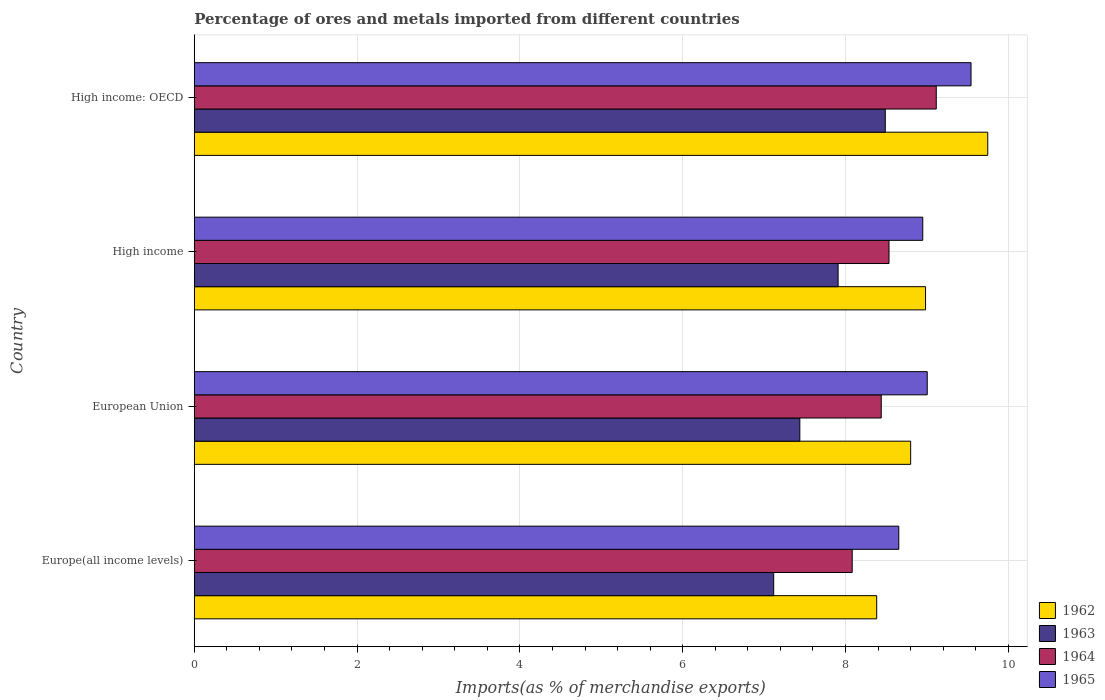How many different coloured bars are there?
Make the answer very short. 4. How many groups of bars are there?
Offer a very short reply. 4. Are the number of bars on each tick of the Y-axis equal?
Your answer should be very brief. Yes. How many bars are there on the 2nd tick from the bottom?
Ensure brevity in your answer.  4. What is the label of the 4th group of bars from the top?
Give a very brief answer. Europe(all income levels). What is the percentage of imports to different countries in 1962 in High income?
Keep it short and to the point. 8.98. Across all countries, what is the maximum percentage of imports to different countries in 1963?
Provide a short and direct response. 8.49. Across all countries, what is the minimum percentage of imports to different countries in 1962?
Provide a short and direct response. 8.38. In which country was the percentage of imports to different countries in 1964 maximum?
Your response must be concise. High income: OECD. In which country was the percentage of imports to different countries in 1962 minimum?
Your answer should be compact. Europe(all income levels). What is the total percentage of imports to different countries in 1965 in the graph?
Your answer should be compact. 36.15. What is the difference between the percentage of imports to different countries in 1962 in European Union and that in High income: OECD?
Make the answer very short. -0.95. What is the difference between the percentage of imports to different countries in 1964 in High income and the percentage of imports to different countries in 1965 in European Union?
Your answer should be compact. -0.47. What is the average percentage of imports to different countries in 1965 per country?
Your answer should be very brief. 9.04. What is the difference between the percentage of imports to different countries in 1962 and percentage of imports to different countries in 1965 in European Union?
Offer a very short reply. -0.2. In how many countries, is the percentage of imports to different countries in 1962 greater than 8.4 %?
Ensure brevity in your answer.  3. What is the ratio of the percentage of imports to different countries in 1962 in European Union to that in High income?
Your response must be concise. 0.98. What is the difference between the highest and the second highest percentage of imports to different countries in 1962?
Offer a very short reply. 0.76. What is the difference between the highest and the lowest percentage of imports to different countries in 1963?
Provide a short and direct response. 1.37. In how many countries, is the percentage of imports to different countries in 1963 greater than the average percentage of imports to different countries in 1963 taken over all countries?
Provide a short and direct response. 2. What does the 1st bar from the top in Europe(all income levels) represents?
Offer a very short reply. 1965. What does the 1st bar from the bottom in High income represents?
Provide a short and direct response. 1962. How many bars are there?
Your response must be concise. 16. What is the difference between two consecutive major ticks on the X-axis?
Keep it short and to the point. 2. Are the values on the major ticks of X-axis written in scientific E-notation?
Give a very brief answer. No. Where does the legend appear in the graph?
Provide a succinct answer. Bottom right. How many legend labels are there?
Ensure brevity in your answer.  4. How are the legend labels stacked?
Your answer should be very brief. Vertical. What is the title of the graph?
Offer a very short reply. Percentage of ores and metals imported from different countries. What is the label or title of the X-axis?
Give a very brief answer. Imports(as % of merchandise exports). What is the label or title of the Y-axis?
Offer a very short reply. Country. What is the Imports(as % of merchandise exports) of 1962 in Europe(all income levels)?
Give a very brief answer. 8.38. What is the Imports(as % of merchandise exports) in 1963 in Europe(all income levels)?
Ensure brevity in your answer.  7.12. What is the Imports(as % of merchandise exports) in 1964 in Europe(all income levels)?
Offer a terse response. 8.08. What is the Imports(as % of merchandise exports) of 1965 in Europe(all income levels)?
Your answer should be compact. 8.65. What is the Imports(as % of merchandise exports) of 1962 in European Union?
Offer a very short reply. 8.8. What is the Imports(as % of merchandise exports) of 1963 in European Union?
Give a very brief answer. 7.44. What is the Imports(as % of merchandise exports) in 1964 in European Union?
Your answer should be compact. 8.44. What is the Imports(as % of merchandise exports) of 1965 in European Union?
Ensure brevity in your answer.  9. What is the Imports(as % of merchandise exports) of 1962 in High income?
Keep it short and to the point. 8.98. What is the Imports(as % of merchandise exports) in 1963 in High income?
Give a very brief answer. 7.91. What is the Imports(as % of merchandise exports) in 1964 in High income?
Ensure brevity in your answer.  8.53. What is the Imports(as % of merchandise exports) of 1965 in High income?
Keep it short and to the point. 8.95. What is the Imports(as % of merchandise exports) in 1962 in High income: OECD?
Make the answer very short. 9.75. What is the Imports(as % of merchandise exports) of 1963 in High income: OECD?
Ensure brevity in your answer.  8.49. What is the Imports(as % of merchandise exports) of 1964 in High income: OECD?
Give a very brief answer. 9.11. What is the Imports(as % of merchandise exports) in 1965 in High income: OECD?
Provide a succinct answer. 9.54. Across all countries, what is the maximum Imports(as % of merchandise exports) in 1962?
Your answer should be compact. 9.75. Across all countries, what is the maximum Imports(as % of merchandise exports) in 1963?
Your answer should be very brief. 8.49. Across all countries, what is the maximum Imports(as % of merchandise exports) in 1964?
Your answer should be compact. 9.11. Across all countries, what is the maximum Imports(as % of merchandise exports) of 1965?
Your response must be concise. 9.54. Across all countries, what is the minimum Imports(as % of merchandise exports) of 1962?
Your answer should be very brief. 8.38. Across all countries, what is the minimum Imports(as % of merchandise exports) of 1963?
Provide a short and direct response. 7.12. Across all countries, what is the minimum Imports(as % of merchandise exports) in 1964?
Offer a very short reply. 8.08. Across all countries, what is the minimum Imports(as % of merchandise exports) of 1965?
Offer a terse response. 8.65. What is the total Imports(as % of merchandise exports) in 1962 in the graph?
Ensure brevity in your answer.  35.91. What is the total Imports(as % of merchandise exports) in 1963 in the graph?
Ensure brevity in your answer.  30.95. What is the total Imports(as % of merchandise exports) of 1964 in the graph?
Offer a terse response. 34.17. What is the total Imports(as % of merchandise exports) in 1965 in the graph?
Keep it short and to the point. 36.15. What is the difference between the Imports(as % of merchandise exports) of 1962 in Europe(all income levels) and that in European Union?
Give a very brief answer. -0.42. What is the difference between the Imports(as % of merchandise exports) of 1963 in Europe(all income levels) and that in European Union?
Keep it short and to the point. -0.32. What is the difference between the Imports(as % of merchandise exports) of 1964 in Europe(all income levels) and that in European Union?
Your answer should be compact. -0.36. What is the difference between the Imports(as % of merchandise exports) of 1965 in Europe(all income levels) and that in European Union?
Offer a terse response. -0.35. What is the difference between the Imports(as % of merchandise exports) in 1962 in Europe(all income levels) and that in High income?
Provide a succinct answer. -0.6. What is the difference between the Imports(as % of merchandise exports) in 1963 in Europe(all income levels) and that in High income?
Make the answer very short. -0.79. What is the difference between the Imports(as % of merchandise exports) in 1964 in Europe(all income levels) and that in High income?
Provide a succinct answer. -0.45. What is the difference between the Imports(as % of merchandise exports) in 1965 in Europe(all income levels) and that in High income?
Give a very brief answer. -0.29. What is the difference between the Imports(as % of merchandise exports) in 1962 in Europe(all income levels) and that in High income: OECD?
Provide a short and direct response. -1.36. What is the difference between the Imports(as % of merchandise exports) in 1963 in Europe(all income levels) and that in High income: OECD?
Provide a succinct answer. -1.37. What is the difference between the Imports(as % of merchandise exports) in 1964 in Europe(all income levels) and that in High income: OECD?
Your response must be concise. -1.03. What is the difference between the Imports(as % of merchandise exports) in 1965 in Europe(all income levels) and that in High income: OECD?
Your answer should be compact. -0.89. What is the difference between the Imports(as % of merchandise exports) of 1962 in European Union and that in High income?
Offer a very short reply. -0.18. What is the difference between the Imports(as % of merchandise exports) in 1963 in European Union and that in High income?
Your answer should be compact. -0.47. What is the difference between the Imports(as % of merchandise exports) in 1964 in European Union and that in High income?
Keep it short and to the point. -0.1. What is the difference between the Imports(as % of merchandise exports) of 1965 in European Union and that in High income?
Offer a very short reply. 0.06. What is the difference between the Imports(as % of merchandise exports) in 1962 in European Union and that in High income: OECD?
Your answer should be compact. -0.95. What is the difference between the Imports(as % of merchandise exports) of 1963 in European Union and that in High income: OECD?
Offer a terse response. -1.05. What is the difference between the Imports(as % of merchandise exports) of 1964 in European Union and that in High income: OECD?
Your answer should be very brief. -0.68. What is the difference between the Imports(as % of merchandise exports) in 1965 in European Union and that in High income: OECD?
Your answer should be very brief. -0.54. What is the difference between the Imports(as % of merchandise exports) of 1962 in High income and that in High income: OECD?
Your answer should be very brief. -0.76. What is the difference between the Imports(as % of merchandise exports) in 1963 in High income and that in High income: OECD?
Make the answer very short. -0.58. What is the difference between the Imports(as % of merchandise exports) in 1964 in High income and that in High income: OECD?
Keep it short and to the point. -0.58. What is the difference between the Imports(as % of merchandise exports) of 1965 in High income and that in High income: OECD?
Your answer should be compact. -0.59. What is the difference between the Imports(as % of merchandise exports) of 1962 in Europe(all income levels) and the Imports(as % of merchandise exports) of 1963 in European Union?
Your answer should be compact. 0.94. What is the difference between the Imports(as % of merchandise exports) in 1962 in Europe(all income levels) and the Imports(as % of merchandise exports) in 1964 in European Union?
Provide a short and direct response. -0.06. What is the difference between the Imports(as % of merchandise exports) in 1962 in Europe(all income levels) and the Imports(as % of merchandise exports) in 1965 in European Union?
Offer a terse response. -0.62. What is the difference between the Imports(as % of merchandise exports) in 1963 in Europe(all income levels) and the Imports(as % of merchandise exports) in 1964 in European Union?
Offer a very short reply. -1.32. What is the difference between the Imports(as % of merchandise exports) in 1963 in Europe(all income levels) and the Imports(as % of merchandise exports) in 1965 in European Union?
Provide a succinct answer. -1.89. What is the difference between the Imports(as % of merchandise exports) in 1964 in Europe(all income levels) and the Imports(as % of merchandise exports) in 1965 in European Union?
Your answer should be compact. -0.92. What is the difference between the Imports(as % of merchandise exports) in 1962 in Europe(all income levels) and the Imports(as % of merchandise exports) in 1963 in High income?
Give a very brief answer. 0.47. What is the difference between the Imports(as % of merchandise exports) in 1962 in Europe(all income levels) and the Imports(as % of merchandise exports) in 1964 in High income?
Your answer should be compact. -0.15. What is the difference between the Imports(as % of merchandise exports) of 1962 in Europe(all income levels) and the Imports(as % of merchandise exports) of 1965 in High income?
Your answer should be compact. -0.57. What is the difference between the Imports(as % of merchandise exports) of 1963 in Europe(all income levels) and the Imports(as % of merchandise exports) of 1964 in High income?
Provide a succinct answer. -1.42. What is the difference between the Imports(as % of merchandise exports) in 1963 in Europe(all income levels) and the Imports(as % of merchandise exports) in 1965 in High income?
Offer a terse response. -1.83. What is the difference between the Imports(as % of merchandise exports) in 1964 in Europe(all income levels) and the Imports(as % of merchandise exports) in 1965 in High income?
Your answer should be very brief. -0.87. What is the difference between the Imports(as % of merchandise exports) in 1962 in Europe(all income levels) and the Imports(as % of merchandise exports) in 1963 in High income: OECD?
Your response must be concise. -0.11. What is the difference between the Imports(as % of merchandise exports) in 1962 in Europe(all income levels) and the Imports(as % of merchandise exports) in 1964 in High income: OECD?
Your answer should be very brief. -0.73. What is the difference between the Imports(as % of merchandise exports) of 1962 in Europe(all income levels) and the Imports(as % of merchandise exports) of 1965 in High income: OECD?
Your response must be concise. -1.16. What is the difference between the Imports(as % of merchandise exports) of 1963 in Europe(all income levels) and the Imports(as % of merchandise exports) of 1964 in High income: OECD?
Provide a short and direct response. -2. What is the difference between the Imports(as % of merchandise exports) of 1963 in Europe(all income levels) and the Imports(as % of merchandise exports) of 1965 in High income: OECD?
Keep it short and to the point. -2.42. What is the difference between the Imports(as % of merchandise exports) in 1964 in Europe(all income levels) and the Imports(as % of merchandise exports) in 1965 in High income: OECD?
Ensure brevity in your answer.  -1.46. What is the difference between the Imports(as % of merchandise exports) in 1962 in European Union and the Imports(as % of merchandise exports) in 1963 in High income?
Offer a very short reply. 0.89. What is the difference between the Imports(as % of merchandise exports) of 1962 in European Union and the Imports(as % of merchandise exports) of 1964 in High income?
Give a very brief answer. 0.27. What is the difference between the Imports(as % of merchandise exports) in 1962 in European Union and the Imports(as % of merchandise exports) in 1965 in High income?
Offer a terse response. -0.15. What is the difference between the Imports(as % of merchandise exports) of 1963 in European Union and the Imports(as % of merchandise exports) of 1964 in High income?
Offer a very short reply. -1.1. What is the difference between the Imports(as % of merchandise exports) in 1963 in European Union and the Imports(as % of merchandise exports) in 1965 in High income?
Give a very brief answer. -1.51. What is the difference between the Imports(as % of merchandise exports) of 1964 in European Union and the Imports(as % of merchandise exports) of 1965 in High income?
Give a very brief answer. -0.51. What is the difference between the Imports(as % of merchandise exports) of 1962 in European Union and the Imports(as % of merchandise exports) of 1963 in High income: OECD?
Offer a very short reply. 0.31. What is the difference between the Imports(as % of merchandise exports) in 1962 in European Union and the Imports(as % of merchandise exports) in 1964 in High income: OECD?
Your response must be concise. -0.31. What is the difference between the Imports(as % of merchandise exports) in 1962 in European Union and the Imports(as % of merchandise exports) in 1965 in High income: OECD?
Offer a terse response. -0.74. What is the difference between the Imports(as % of merchandise exports) in 1963 in European Union and the Imports(as % of merchandise exports) in 1964 in High income: OECD?
Offer a very short reply. -1.68. What is the difference between the Imports(as % of merchandise exports) of 1963 in European Union and the Imports(as % of merchandise exports) of 1965 in High income: OECD?
Keep it short and to the point. -2.1. What is the difference between the Imports(as % of merchandise exports) in 1964 in European Union and the Imports(as % of merchandise exports) in 1965 in High income: OECD?
Your answer should be compact. -1.1. What is the difference between the Imports(as % of merchandise exports) in 1962 in High income and the Imports(as % of merchandise exports) in 1963 in High income: OECD?
Make the answer very short. 0.49. What is the difference between the Imports(as % of merchandise exports) in 1962 in High income and the Imports(as % of merchandise exports) in 1964 in High income: OECD?
Ensure brevity in your answer.  -0.13. What is the difference between the Imports(as % of merchandise exports) of 1962 in High income and the Imports(as % of merchandise exports) of 1965 in High income: OECD?
Your answer should be compact. -0.56. What is the difference between the Imports(as % of merchandise exports) in 1963 in High income and the Imports(as % of merchandise exports) in 1964 in High income: OECD?
Make the answer very short. -1.21. What is the difference between the Imports(as % of merchandise exports) in 1963 in High income and the Imports(as % of merchandise exports) in 1965 in High income: OECD?
Provide a succinct answer. -1.63. What is the difference between the Imports(as % of merchandise exports) of 1964 in High income and the Imports(as % of merchandise exports) of 1965 in High income: OECD?
Your answer should be compact. -1.01. What is the average Imports(as % of merchandise exports) in 1962 per country?
Keep it short and to the point. 8.98. What is the average Imports(as % of merchandise exports) in 1963 per country?
Your answer should be very brief. 7.74. What is the average Imports(as % of merchandise exports) in 1964 per country?
Provide a short and direct response. 8.54. What is the average Imports(as % of merchandise exports) of 1965 per country?
Your response must be concise. 9.04. What is the difference between the Imports(as % of merchandise exports) in 1962 and Imports(as % of merchandise exports) in 1963 in Europe(all income levels)?
Ensure brevity in your answer.  1.26. What is the difference between the Imports(as % of merchandise exports) in 1962 and Imports(as % of merchandise exports) in 1964 in Europe(all income levels)?
Your answer should be compact. 0.3. What is the difference between the Imports(as % of merchandise exports) of 1962 and Imports(as % of merchandise exports) of 1965 in Europe(all income levels)?
Ensure brevity in your answer.  -0.27. What is the difference between the Imports(as % of merchandise exports) in 1963 and Imports(as % of merchandise exports) in 1964 in Europe(all income levels)?
Offer a terse response. -0.96. What is the difference between the Imports(as % of merchandise exports) in 1963 and Imports(as % of merchandise exports) in 1965 in Europe(all income levels)?
Provide a short and direct response. -1.54. What is the difference between the Imports(as % of merchandise exports) in 1964 and Imports(as % of merchandise exports) in 1965 in Europe(all income levels)?
Keep it short and to the point. -0.57. What is the difference between the Imports(as % of merchandise exports) of 1962 and Imports(as % of merchandise exports) of 1963 in European Union?
Ensure brevity in your answer.  1.36. What is the difference between the Imports(as % of merchandise exports) of 1962 and Imports(as % of merchandise exports) of 1964 in European Union?
Ensure brevity in your answer.  0.36. What is the difference between the Imports(as % of merchandise exports) of 1962 and Imports(as % of merchandise exports) of 1965 in European Union?
Your answer should be very brief. -0.2. What is the difference between the Imports(as % of merchandise exports) in 1963 and Imports(as % of merchandise exports) in 1964 in European Union?
Offer a very short reply. -1. What is the difference between the Imports(as % of merchandise exports) of 1963 and Imports(as % of merchandise exports) of 1965 in European Union?
Make the answer very short. -1.57. What is the difference between the Imports(as % of merchandise exports) of 1964 and Imports(as % of merchandise exports) of 1965 in European Union?
Offer a terse response. -0.56. What is the difference between the Imports(as % of merchandise exports) in 1962 and Imports(as % of merchandise exports) in 1963 in High income?
Your answer should be very brief. 1.07. What is the difference between the Imports(as % of merchandise exports) in 1962 and Imports(as % of merchandise exports) in 1964 in High income?
Your answer should be very brief. 0.45. What is the difference between the Imports(as % of merchandise exports) in 1962 and Imports(as % of merchandise exports) in 1965 in High income?
Ensure brevity in your answer.  0.03. What is the difference between the Imports(as % of merchandise exports) in 1963 and Imports(as % of merchandise exports) in 1964 in High income?
Your answer should be very brief. -0.63. What is the difference between the Imports(as % of merchandise exports) of 1963 and Imports(as % of merchandise exports) of 1965 in High income?
Your answer should be compact. -1.04. What is the difference between the Imports(as % of merchandise exports) in 1964 and Imports(as % of merchandise exports) in 1965 in High income?
Keep it short and to the point. -0.41. What is the difference between the Imports(as % of merchandise exports) in 1962 and Imports(as % of merchandise exports) in 1963 in High income: OECD?
Give a very brief answer. 1.26. What is the difference between the Imports(as % of merchandise exports) of 1962 and Imports(as % of merchandise exports) of 1964 in High income: OECD?
Your answer should be compact. 0.63. What is the difference between the Imports(as % of merchandise exports) of 1962 and Imports(as % of merchandise exports) of 1965 in High income: OECD?
Give a very brief answer. 0.21. What is the difference between the Imports(as % of merchandise exports) of 1963 and Imports(as % of merchandise exports) of 1964 in High income: OECD?
Your answer should be compact. -0.63. What is the difference between the Imports(as % of merchandise exports) of 1963 and Imports(as % of merchandise exports) of 1965 in High income: OECD?
Ensure brevity in your answer.  -1.05. What is the difference between the Imports(as % of merchandise exports) in 1964 and Imports(as % of merchandise exports) in 1965 in High income: OECD?
Offer a very short reply. -0.43. What is the ratio of the Imports(as % of merchandise exports) in 1962 in Europe(all income levels) to that in European Union?
Give a very brief answer. 0.95. What is the ratio of the Imports(as % of merchandise exports) in 1963 in Europe(all income levels) to that in European Union?
Provide a succinct answer. 0.96. What is the ratio of the Imports(as % of merchandise exports) in 1964 in Europe(all income levels) to that in European Union?
Provide a succinct answer. 0.96. What is the ratio of the Imports(as % of merchandise exports) in 1965 in Europe(all income levels) to that in European Union?
Offer a very short reply. 0.96. What is the ratio of the Imports(as % of merchandise exports) of 1962 in Europe(all income levels) to that in High income?
Your response must be concise. 0.93. What is the ratio of the Imports(as % of merchandise exports) of 1964 in Europe(all income levels) to that in High income?
Give a very brief answer. 0.95. What is the ratio of the Imports(as % of merchandise exports) of 1965 in Europe(all income levels) to that in High income?
Ensure brevity in your answer.  0.97. What is the ratio of the Imports(as % of merchandise exports) of 1962 in Europe(all income levels) to that in High income: OECD?
Offer a very short reply. 0.86. What is the ratio of the Imports(as % of merchandise exports) of 1963 in Europe(all income levels) to that in High income: OECD?
Offer a very short reply. 0.84. What is the ratio of the Imports(as % of merchandise exports) of 1964 in Europe(all income levels) to that in High income: OECD?
Your answer should be compact. 0.89. What is the ratio of the Imports(as % of merchandise exports) of 1965 in Europe(all income levels) to that in High income: OECD?
Your answer should be very brief. 0.91. What is the ratio of the Imports(as % of merchandise exports) of 1962 in European Union to that in High income?
Give a very brief answer. 0.98. What is the ratio of the Imports(as % of merchandise exports) in 1963 in European Union to that in High income?
Your answer should be very brief. 0.94. What is the ratio of the Imports(as % of merchandise exports) of 1965 in European Union to that in High income?
Ensure brevity in your answer.  1.01. What is the ratio of the Imports(as % of merchandise exports) of 1962 in European Union to that in High income: OECD?
Your response must be concise. 0.9. What is the ratio of the Imports(as % of merchandise exports) in 1963 in European Union to that in High income: OECD?
Give a very brief answer. 0.88. What is the ratio of the Imports(as % of merchandise exports) in 1964 in European Union to that in High income: OECD?
Provide a succinct answer. 0.93. What is the ratio of the Imports(as % of merchandise exports) in 1965 in European Union to that in High income: OECD?
Offer a very short reply. 0.94. What is the ratio of the Imports(as % of merchandise exports) in 1962 in High income to that in High income: OECD?
Provide a succinct answer. 0.92. What is the ratio of the Imports(as % of merchandise exports) of 1963 in High income to that in High income: OECD?
Your answer should be very brief. 0.93. What is the ratio of the Imports(as % of merchandise exports) of 1964 in High income to that in High income: OECD?
Your response must be concise. 0.94. What is the ratio of the Imports(as % of merchandise exports) in 1965 in High income to that in High income: OECD?
Offer a terse response. 0.94. What is the difference between the highest and the second highest Imports(as % of merchandise exports) of 1962?
Give a very brief answer. 0.76. What is the difference between the highest and the second highest Imports(as % of merchandise exports) of 1963?
Offer a very short reply. 0.58. What is the difference between the highest and the second highest Imports(as % of merchandise exports) in 1964?
Your answer should be compact. 0.58. What is the difference between the highest and the second highest Imports(as % of merchandise exports) of 1965?
Ensure brevity in your answer.  0.54. What is the difference between the highest and the lowest Imports(as % of merchandise exports) of 1962?
Your answer should be compact. 1.36. What is the difference between the highest and the lowest Imports(as % of merchandise exports) in 1963?
Provide a succinct answer. 1.37. What is the difference between the highest and the lowest Imports(as % of merchandise exports) of 1964?
Keep it short and to the point. 1.03. What is the difference between the highest and the lowest Imports(as % of merchandise exports) in 1965?
Your answer should be very brief. 0.89. 